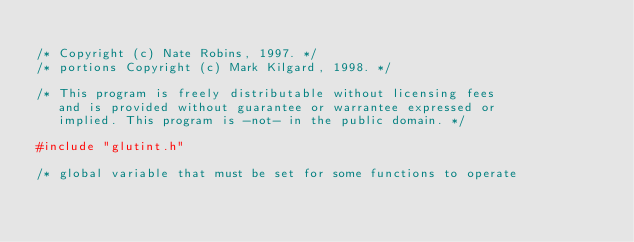Convert code to text. <code><loc_0><loc_0><loc_500><loc_500><_C_>
/* Copyright (c) Nate Robins, 1997. */
/* portions Copyright (c) Mark Kilgard, 1998. */

/* This program is freely distributable without licensing fees 
   and is provided without guarantee or warrantee expressed or 
   implied. This program is -not- in the public domain. */

#include "glutint.h"

/* global variable that must be set for some functions to operate</code> 